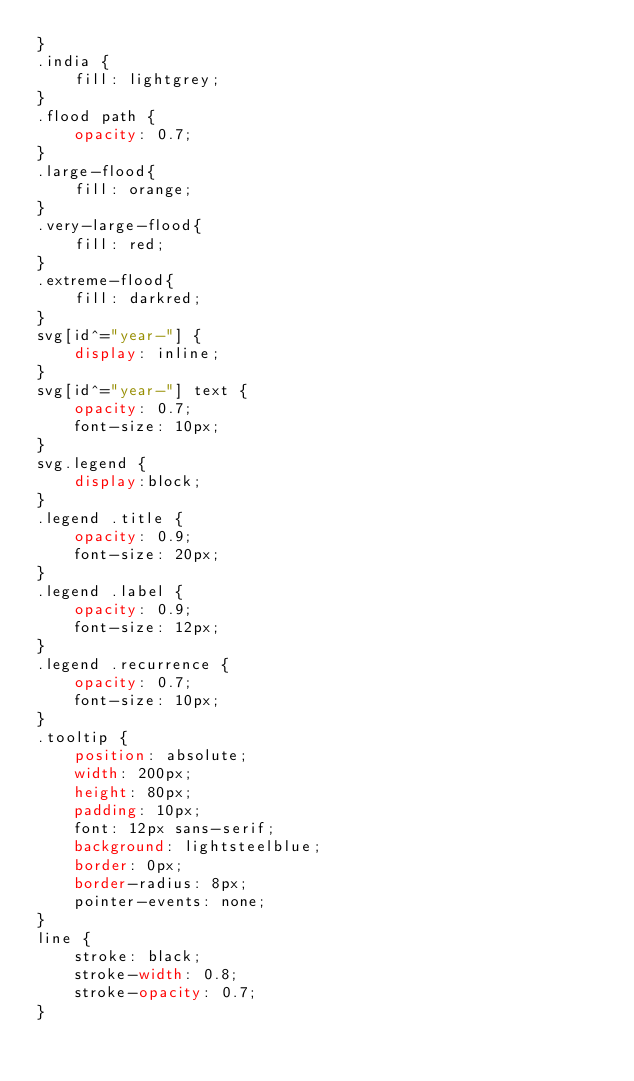<code> <loc_0><loc_0><loc_500><loc_500><_CSS_>}
.india {
    fill: lightgrey;
}
.flood path {
    opacity: 0.7;
}
.large-flood{
    fill: orange;
}
.very-large-flood{
    fill: red;
}
.extreme-flood{
    fill: darkred;
}
svg[id^="year-"] {
    display: inline;
}
svg[id^="year-"] text {
    opacity: 0.7;
    font-size: 10px;
}
svg.legend {
    display:block;
}
.legend .title {
    opacity: 0.9;
    font-size: 20px;
}
.legend .label {
    opacity: 0.9;
    font-size: 12px;
}
.legend .recurrence {
    opacity: 0.7;
    font-size: 10px;
}
.tooltip {
    position: absolute;
    width: 200px;
    height: 80px;
    padding: 10px;
    font: 12px sans-serif;
    background: lightsteelblue;
    border: 0px;
    border-radius: 8px;
    pointer-events: none;
}
line {
    stroke: black;
    stroke-width: 0.8;
    stroke-opacity: 0.7;
}
</code> 